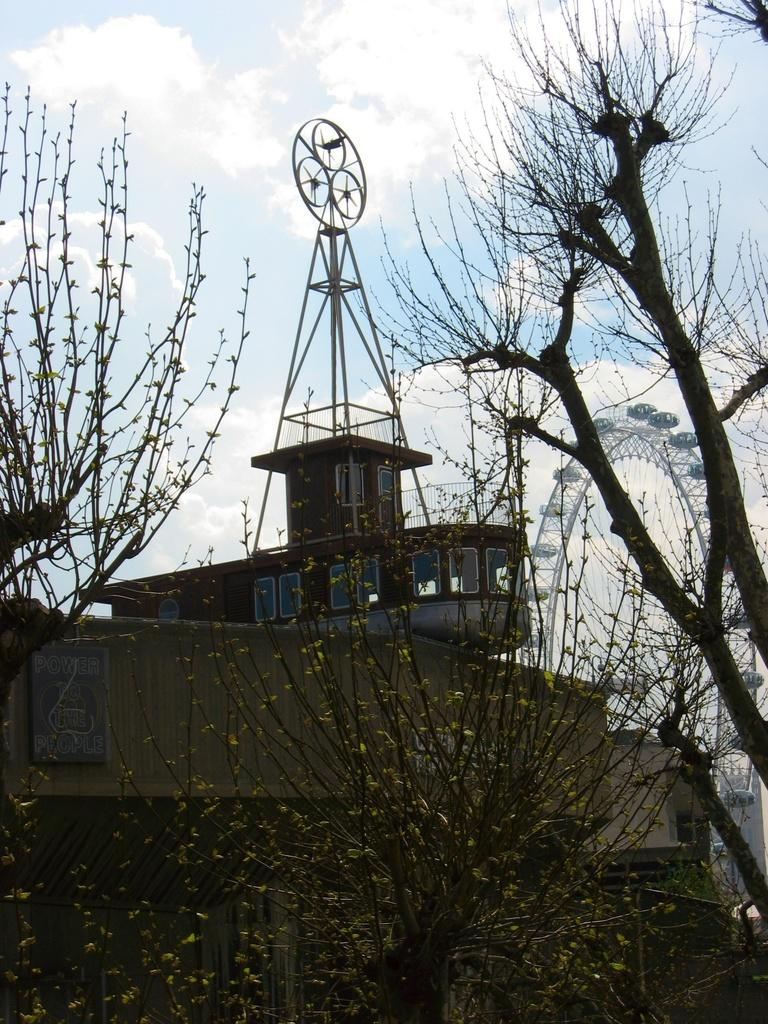What type of vegetation is visible in the front of the image? There are trees in the front of the image. What type of structure can be seen in the background of the image? There is a building in the background of the image. What is the condition of the sky in the image? The sky is cloudy in the image. What type of jam is being served at the sea in the image? There is no jam or sea present in the image; it features trees, a building, and a cloudy sky. 